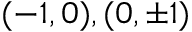<formula> <loc_0><loc_0><loc_500><loc_500>( - 1 , 0 ) , ( 0 , \pm 1 )</formula> 